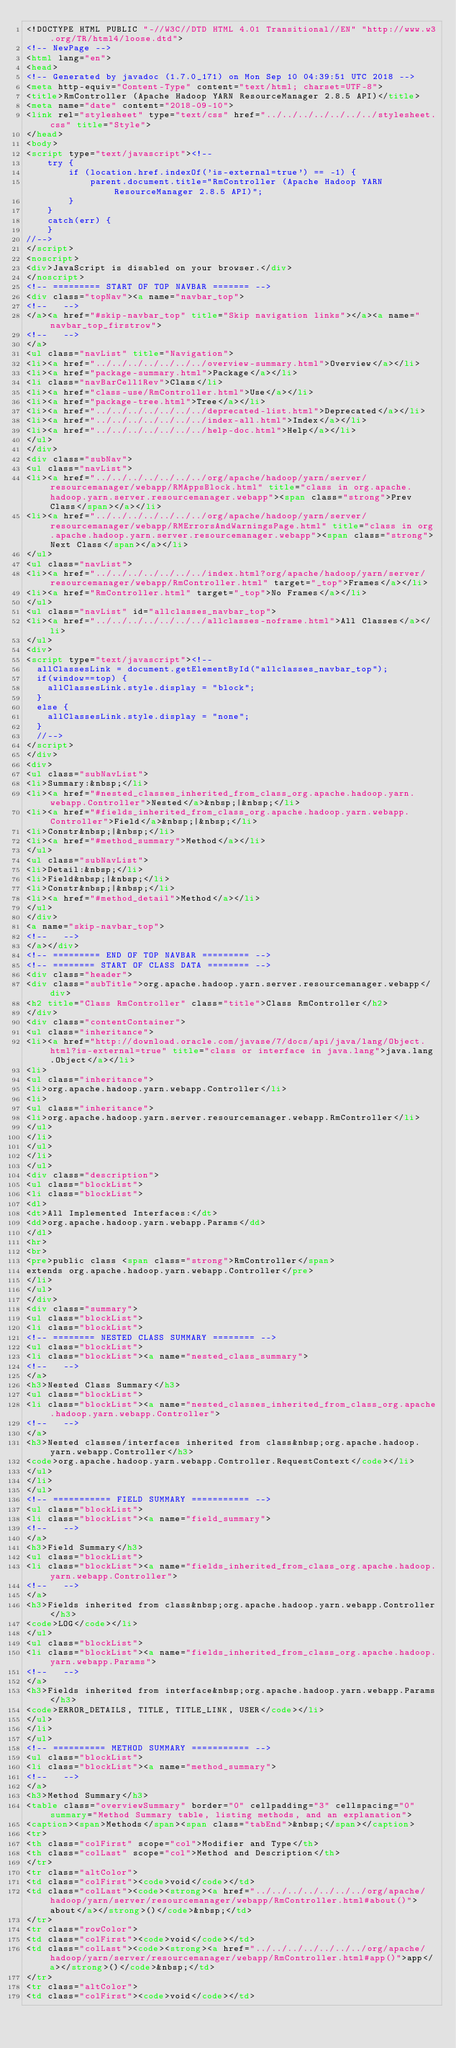Convert code to text. <code><loc_0><loc_0><loc_500><loc_500><_HTML_><!DOCTYPE HTML PUBLIC "-//W3C//DTD HTML 4.01 Transitional//EN" "http://www.w3.org/TR/html4/loose.dtd">
<!-- NewPage -->
<html lang="en">
<head>
<!-- Generated by javadoc (1.7.0_171) on Mon Sep 10 04:39:51 UTC 2018 -->
<meta http-equiv="Content-Type" content="text/html; charset=UTF-8">
<title>RmController (Apache Hadoop YARN ResourceManager 2.8.5 API)</title>
<meta name="date" content="2018-09-10">
<link rel="stylesheet" type="text/css" href="../../../../../../../stylesheet.css" title="Style">
</head>
<body>
<script type="text/javascript"><!--
    try {
        if (location.href.indexOf('is-external=true') == -1) {
            parent.document.title="RmController (Apache Hadoop YARN ResourceManager 2.8.5 API)";
        }
    }
    catch(err) {
    }
//-->
</script>
<noscript>
<div>JavaScript is disabled on your browser.</div>
</noscript>
<!-- ========= START OF TOP NAVBAR ======= -->
<div class="topNav"><a name="navbar_top">
<!--   -->
</a><a href="#skip-navbar_top" title="Skip navigation links"></a><a name="navbar_top_firstrow">
<!--   -->
</a>
<ul class="navList" title="Navigation">
<li><a href="../../../../../../../overview-summary.html">Overview</a></li>
<li><a href="package-summary.html">Package</a></li>
<li class="navBarCell1Rev">Class</li>
<li><a href="class-use/RmController.html">Use</a></li>
<li><a href="package-tree.html">Tree</a></li>
<li><a href="../../../../../../../deprecated-list.html">Deprecated</a></li>
<li><a href="../../../../../../../index-all.html">Index</a></li>
<li><a href="../../../../../../../help-doc.html">Help</a></li>
</ul>
</div>
<div class="subNav">
<ul class="navList">
<li><a href="../../../../../../../org/apache/hadoop/yarn/server/resourcemanager/webapp/RMAppsBlock.html" title="class in org.apache.hadoop.yarn.server.resourcemanager.webapp"><span class="strong">Prev Class</span></a></li>
<li><a href="../../../../../../../org/apache/hadoop/yarn/server/resourcemanager/webapp/RMErrorsAndWarningsPage.html" title="class in org.apache.hadoop.yarn.server.resourcemanager.webapp"><span class="strong">Next Class</span></a></li>
</ul>
<ul class="navList">
<li><a href="../../../../../../../index.html?org/apache/hadoop/yarn/server/resourcemanager/webapp/RmController.html" target="_top">Frames</a></li>
<li><a href="RmController.html" target="_top">No Frames</a></li>
</ul>
<ul class="navList" id="allclasses_navbar_top">
<li><a href="../../../../../../../allclasses-noframe.html">All Classes</a></li>
</ul>
<div>
<script type="text/javascript"><!--
  allClassesLink = document.getElementById("allclasses_navbar_top");
  if(window==top) {
    allClassesLink.style.display = "block";
  }
  else {
    allClassesLink.style.display = "none";
  }
  //-->
</script>
</div>
<div>
<ul class="subNavList">
<li>Summary:&nbsp;</li>
<li><a href="#nested_classes_inherited_from_class_org.apache.hadoop.yarn.webapp.Controller">Nested</a>&nbsp;|&nbsp;</li>
<li><a href="#fields_inherited_from_class_org.apache.hadoop.yarn.webapp.Controller">Field</a>&nbsp;|&nbsp;</li>
<li>Constr&nbsp;|&nbsp;</li>
<li><a href="#method_summary">Method</a></li>
</ul>
<ul class="subNavList">
<li>Detail:&nbsp;</li>
<li>Field&nbsp;|&nbsp;</li>
<li>Constr&nbsp;|&nbsp;</li>
<li><a href="#method_detail">Method</a></li>
</ul>
</div>
<a name="skip-navbar_top">
<!--   -->
</a></div>
<!-- ========= END OF TOP NAVBAR ========= -->
<!-- ======== START OF CLASS DATA ======== -->
<div class="header">
<div class="subTitle">org.apache.hadoop.yarn.server.resourcemanager.webapp</div>
<h2 title="Class RmController" class="title">Class RmController</h2>
</div>
<div class="contentContainer">
<ul class="inheritance">
<li><a href="http://download.oracle.com/javase/7/docs/api/java/lang/Object.html?is-external=true" title="class or interface in java.lang">java.lang.Object</a></li>
<li>
<ul class="inheritance">
<li>org.apache.hadoop.yarn.webapp.Controller</li>
<li>
<ul class="inheritance">
<li>org.apache.hadoop.yarn.server.resourcemanager.webapp.RmController</li>
</ul>
</li>
</ul>
</li>
</ul>
<div class="description">
<ul class="blockList">
<li class="blockList">
<dl>
<dt>All Implemented Interfaces:</dt>
<dd>org.apache.hadoop.yarn.webapp.Params</dd>
</dl>
<hr>
<br>
<pre>public class <span class="strong">RmController</span>
extends org.apache.hadoop.yarn.webapp.Controller</pre>
</li>
</ul>
</div>
<div class="summary">
<ul class="blockList">
<li class="blockList">
<!-- ======== NESTED CLASS SUMMARY ======== -->
<ul class="blockList">
<li class="blockList"><a name="nested_class_summary">
<!--   -->
</a>
<h3>Nested Class Summary</h3>
<ul class="blockList">
<li class="blockList"><a name="nested_classes_inherited_from_class_org.apache.hadoop.yarn.webapp.Controller">
<!--   -->
</a>
<h3>Nested classes/interfaces inherited from class&nbsp;org.apache.hadoop.yarn.webapp.Controller</h3>
<code>org.apache.hadoop.yarn.webapp.Controller.RequestContext</code></li>
</ul>
</li>
</ul>
<!-- =========== FIELD SUMMARY =========== -->
<ul class="blockList">
<li class="blockList"><a name="field_summary">
<!--   -->
</a>
<h3>Field Summary</h3>
<ul class="blockList">
<li class="blockList"><a name="fields_inherited_from_class_org.apache.hadoop.yarn.webapp.Controller">
<!--   -->
</a>
<h3>Fields inherited from class&nbsp;org.apache.hadoop.yarn.webapp.Controller</h3>
<code>LOG</code></li>
</ul>
<ul class="blockList">
<li class="blockList"><a name="fields_inherited_from_class_org.apache.hadoop.yarn.webapp.Params">
<!--   -->
</a>
<h3>Fields inherited from interface&nbsp;org.apache.hadoop.yarn.webapp.Params</h3>
<code>ERROR_DETAILS, TITLE, TITLE_LINK, USER</code></li>
</ul>
</li>
</ul>
<!-- ========== METHOD SUMMARY =========== -->
<ul class="blockList">
<li class="blockList"><a name="method_summary">
<!--   -->
</a>
<h3>Method Summary</h3>
<table class="overviewSummary" border="0" cellpadding="3" cellspacing="0" summary="Method Summary table, listing methods, and an explanation">
<caption><span>Methods</span><span class="tabEnd">&nbsp;</span></caption>
<tr>
<th class="colFirst" scope="col">Modifier and Type</th>
<th class="colLast" scope="col">Method and Description</th>
</tr>
<tr class="altColor">
<td class="colFirst"><code>void</code></td>
<td class="colLast"><code><strong><a href="../../../../../../../org/apache/hadoop/yarn/server/resourcemanager/webapp/RmController.html#about()">about</a></strong>()</code>&nbsp;</td>
</tr>
<tr class="rowColor">
<td class="colFirst"><code>void</code></td>
<td class="colLast"><code><strong><a href="../../../../../../../org/apache/hadoop/yarn/server/resourcemanager/webapp/RmController.html#app()">app</a></strong>()</code>&nbsp;</td>
</tr>
<tr class="altColor">
<td class="colFirst"><code>void</code></td></code> 